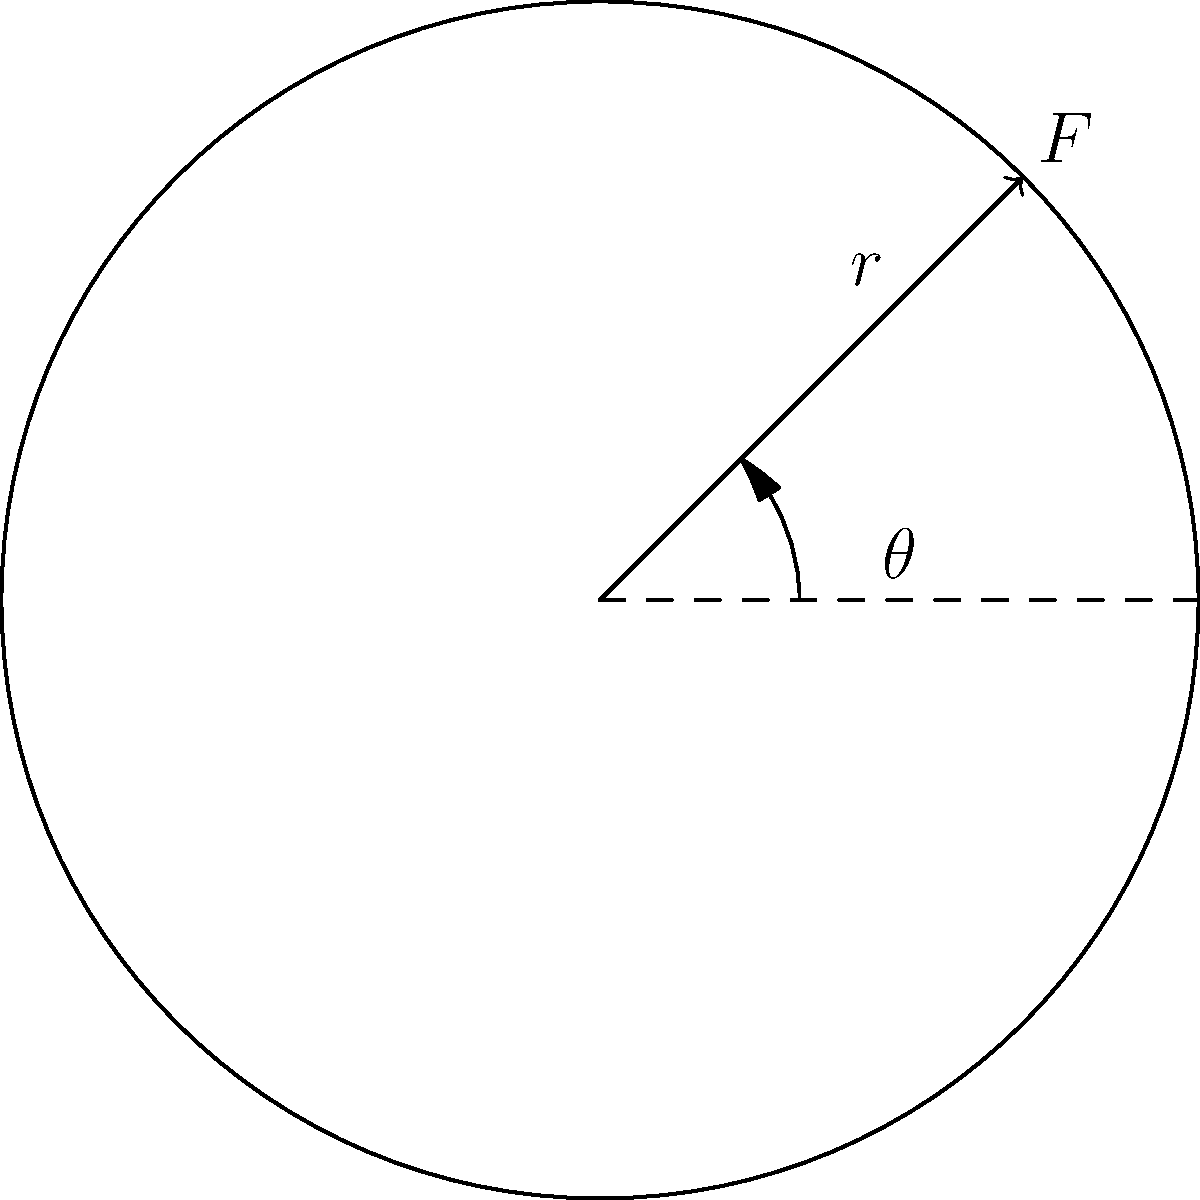In cycling biomechanics, the power output during a pedal stroke is influenced by the angle of force application. Given a pedal radius of 17 cm and a constant force magnitude of 250 N, at what angle $\theta$ (in degrees) should the force be applied to maximize power output? To solve this problem, we need to follow these steps:

1) The power output in a rotational system is given by:
   $$P = \tau \omega$$
   where $P$ is power, $\tau$ is torque, and $\omega$ is angular velocity.

2) Since we want to maximize power and angular velocity is constant for a given pedaling cadence, we need to maximize torque.

3) Torque is calculated as:
   $$\tau = rF\sin\theta$$
   where $r$ is the pedal radius, $F$ is the applied force, and $\theta$ is the angle between the force vector and the radial direction.

4) To find the maximum torque, we need to maximize $\sin\theta$.

5) The maximum value of $\sin\theta$ occurs when $\theta = 90°$.

6) Therefore, the optimal angle for maximum power output is 90° (perpendicular to the radial direction).

This result aligns with the principle that force application perpendicular to the lever arm (in this case, the pedal crank) produces the maximum torque and, consequently, the maximum power output.
Answer: 90° 